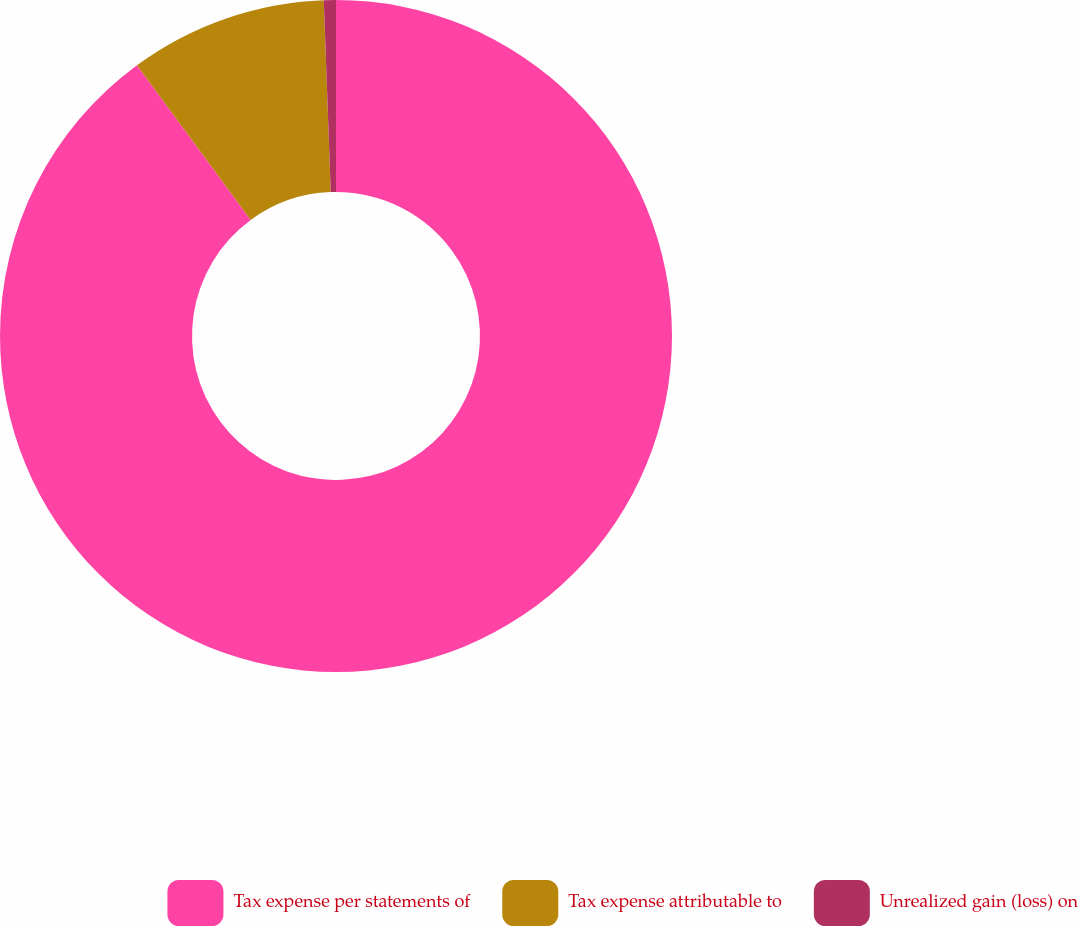<chart> <loc_0><loc_0><loc_500><loc_500><pie_chart><fcel>Tax expense per statements of<fcel>Tax expense attributable to<fcel>Unrealized gain (loss) on<nl><fcel>89.91%<fcel>9.51%<fcel>0.58%<nl></chart> 